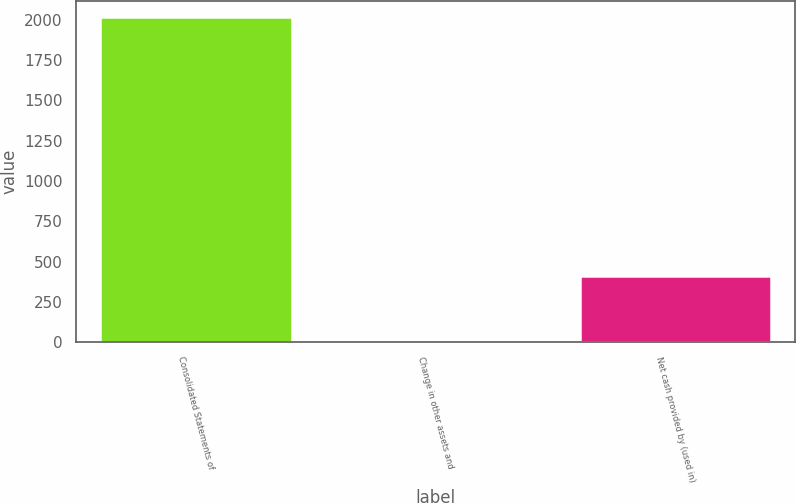<chart> <loc_0><loc_0><loc_500><loc_500><bar_chart><fcel>Consolidated Statements of<fcel>Change in other assets and<fcel>Net cash provided by (used in)<nl><fcel>2016<fcel>10.6<fcel>411.68<nl></chart> 